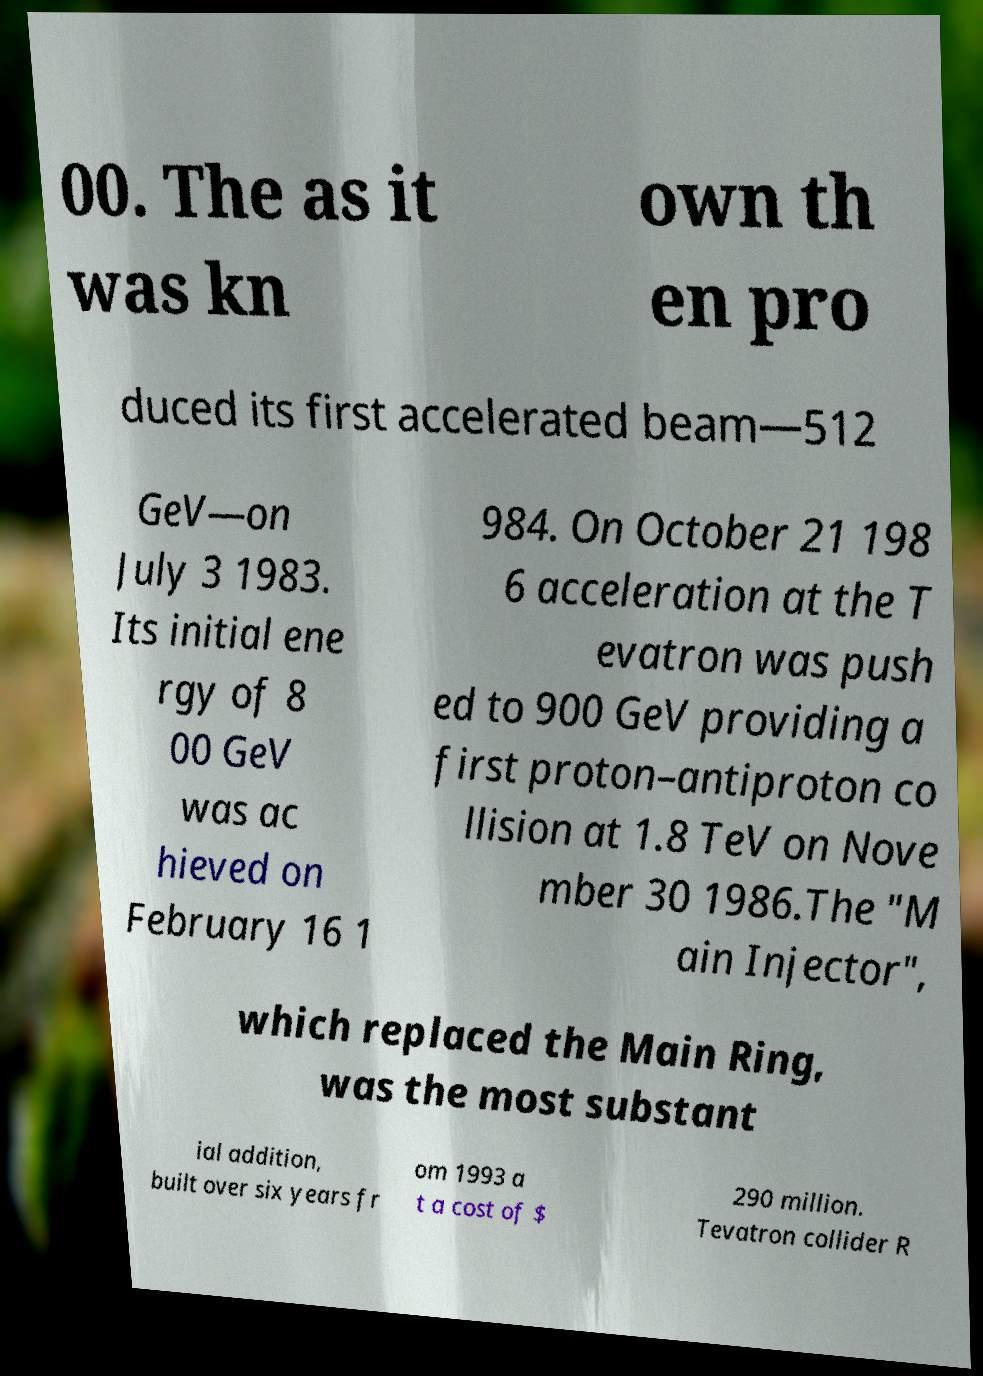I need the written content from this picture converted into text. Can you do that? 00. The as it was kn own th en pro duced its first accelerated beam—512 GeV—on July 3 1983. Its initial ene rgy of 8 00 GeV was ac hieved on February 16 1 984. On October 21 198 6 acceleration at the T evatron was push ed to 900 GeV providing a first proton–antiproton co llision at 1.8 TeV on Nove mber 30 1986.The "M ain Injector", which replaced the Main Ring, was the most substant ial addition, built over six years fr om 1993 a t a cost of $ 290 million. Tevatron collider R 